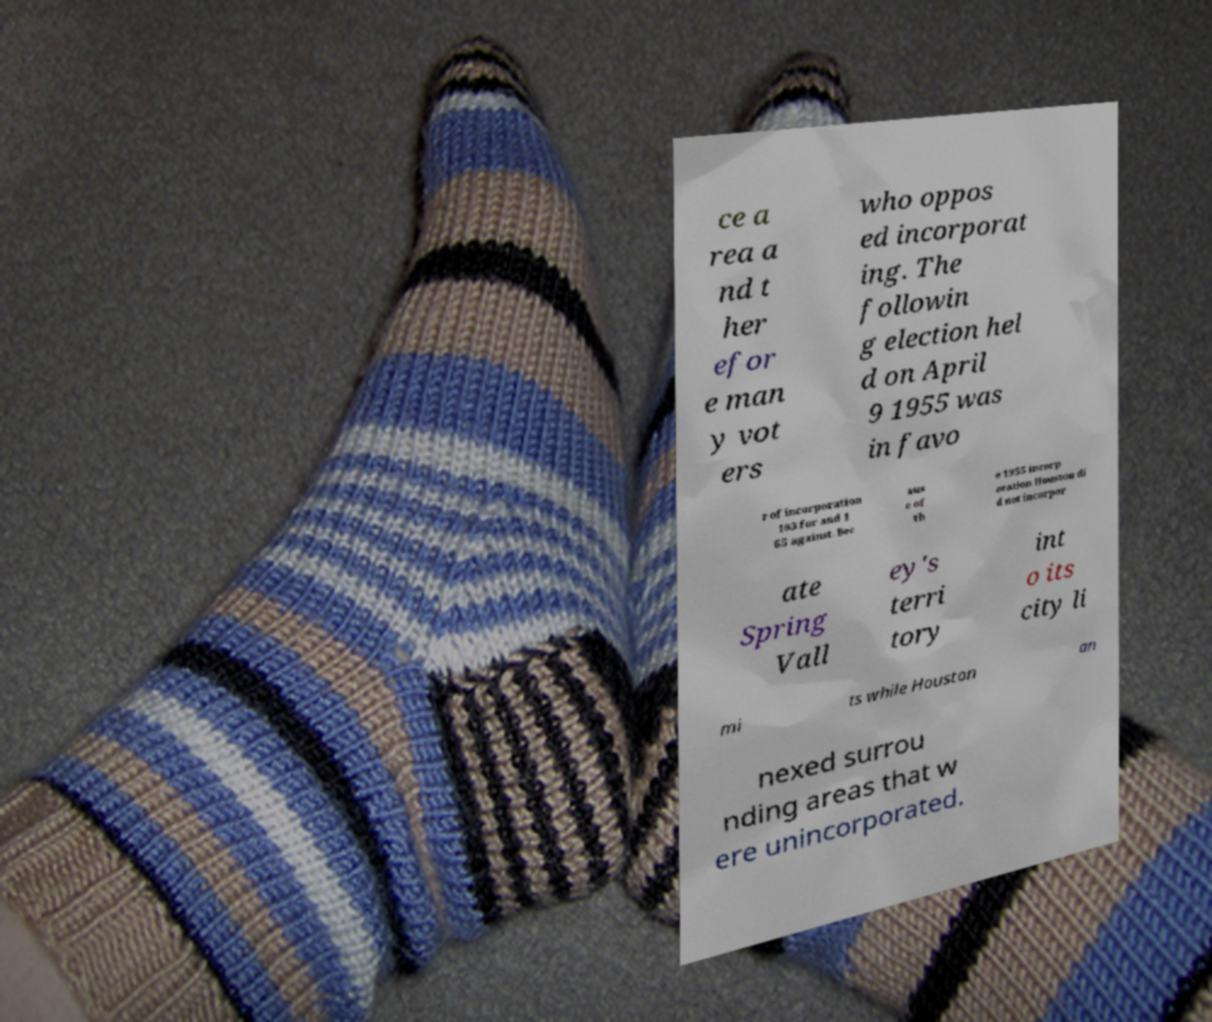What messages or text are displayed in this image? I need them in a readable, typed format. ce a rea a nd t her efor e man y vot ers who oppos ed incorporat ing. The followin g election hel d on April 9 1955 was in favo r of incorporation 183 for and 1 65 against. Bec aus e of th e 1955 incorp oration Houston di d not incorpor ate Spring Vall ey's terri tory int o its city li mi ts while Houston an nexed surrou nding areas that w ere unincorporated. 